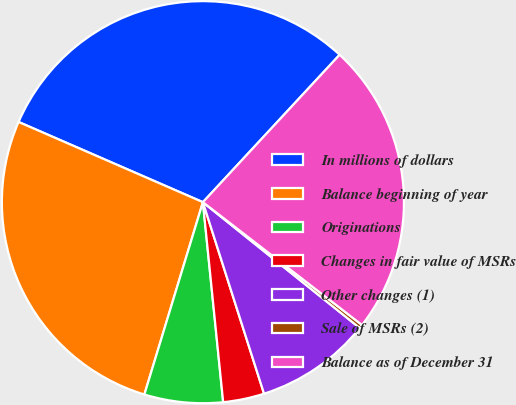Convert chart to OTSL. <chart><loc_0><loc_0><loc_500><loc_500><pie_chart><fcel>In millions of dollars<fcel>Balance beginning of year<fcel>Originations<fcel>Changes in fair value of MSRs<fcel>Other changes (1)<fcel>Sale of MSRs (2)<fcel>Balance as of December 31<nl><fcel>30.37%<fcel>26.83%<fcel>6.31%<fcel>3.31%<fcel>9.32%<fcel>0.3%<fcel>23.56%<nl></chart> 